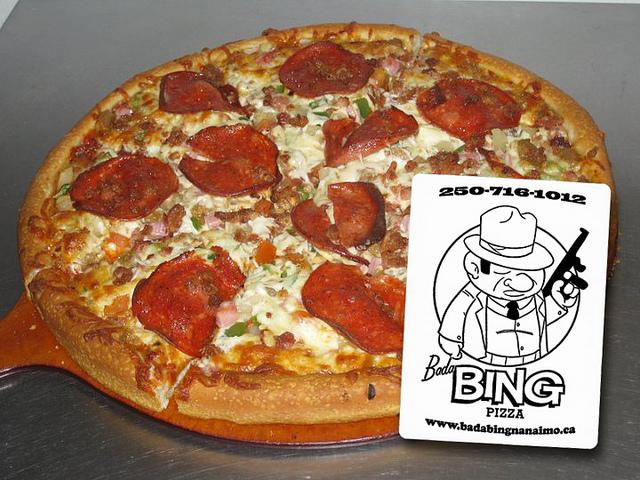Is the pizza in a pan?
Answer briefly. No. What kind of pizza is this?
Concise answer only. Pepperoni. Is this a typical place to find a pizza?
Write a very short answer. Yes. Where is the pizza from?
Short answer required. Bada bing. Does the pizza have olives on it?
Keep it brief. No. What is the red stuff on the pizza?
Be succinct. Pepperoni. Is this breakfast food?
Write a very short answer. No. Is this a deep dish pizza?
Concise answer only. Yes. Is this pizza handmade?
Be succinct. Yes. What nation is the book on the table about?
Be succinct. Italy. What is round on the pizza?
Keep it brief. Pepperoni. 